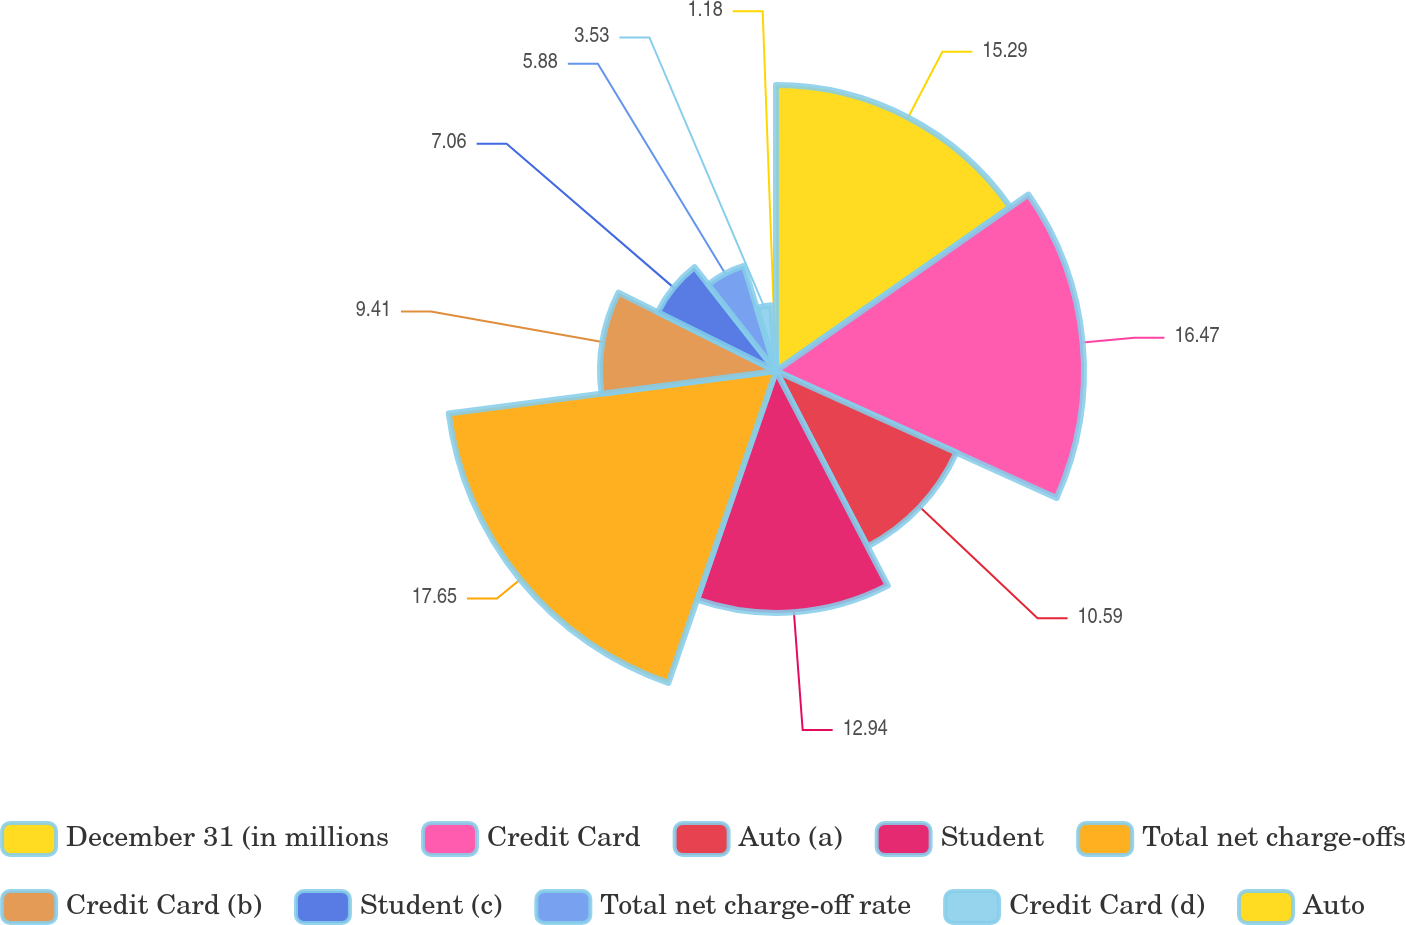<chart> <loc_0><loc_0><loc_500><loc_500><pie_chart><fcel>December 31 (in millions<fcel>Credit Card<fcel>Auto (a)<fcel>Student<fcel>Total net charge-offs<fcel>Credit Card (b)<fcel>Student (c)<fcel>Total net charge-off rate<fcel>Credit Card (d)<fcel>Auto<nl><fcel>15.29%<fcel>16.47%<fcel>10.59%<fcel>12.94%<fcel>17.65%<fcel>9.41%<fcel>7.06%<fcel>5.88%<fcel>3.53%<fcel>1.18%<nl></chart> 